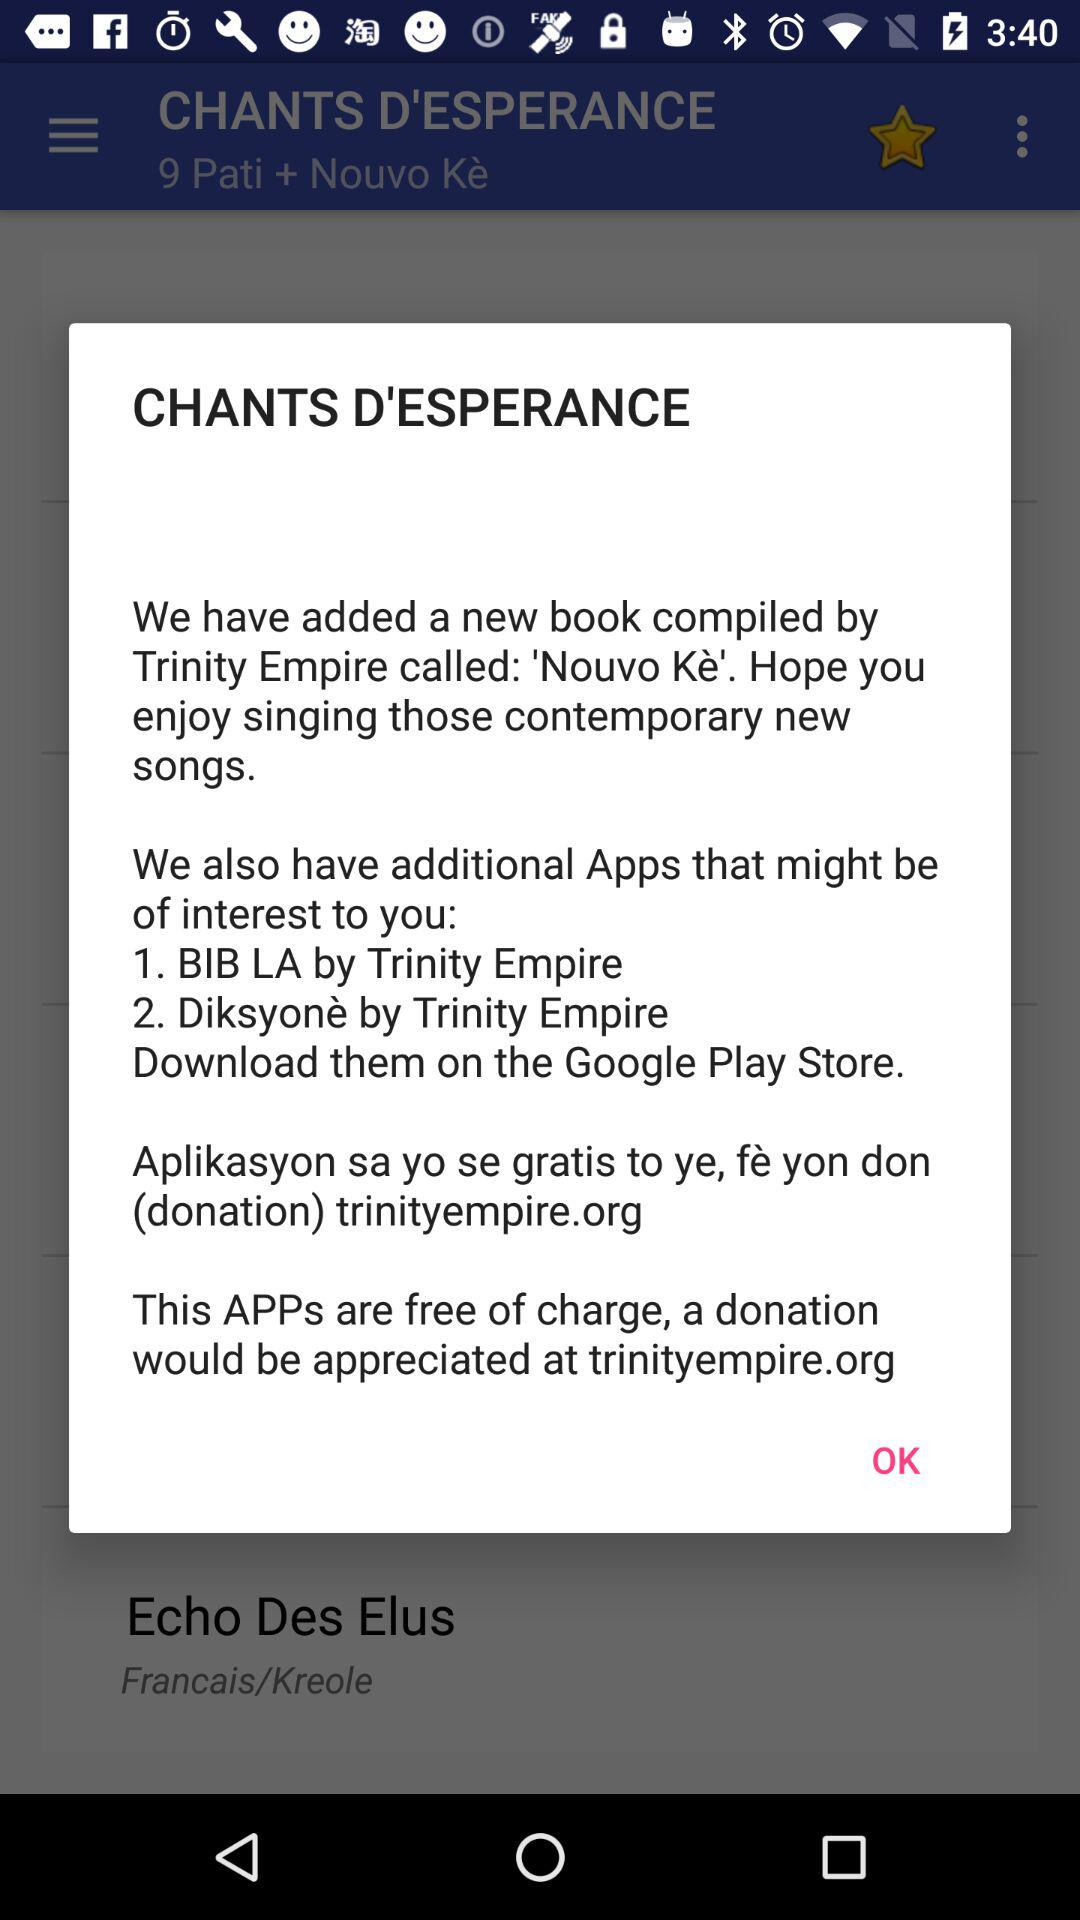How many additional apps are offered?
Answer the question using a single word or phrase. 2 